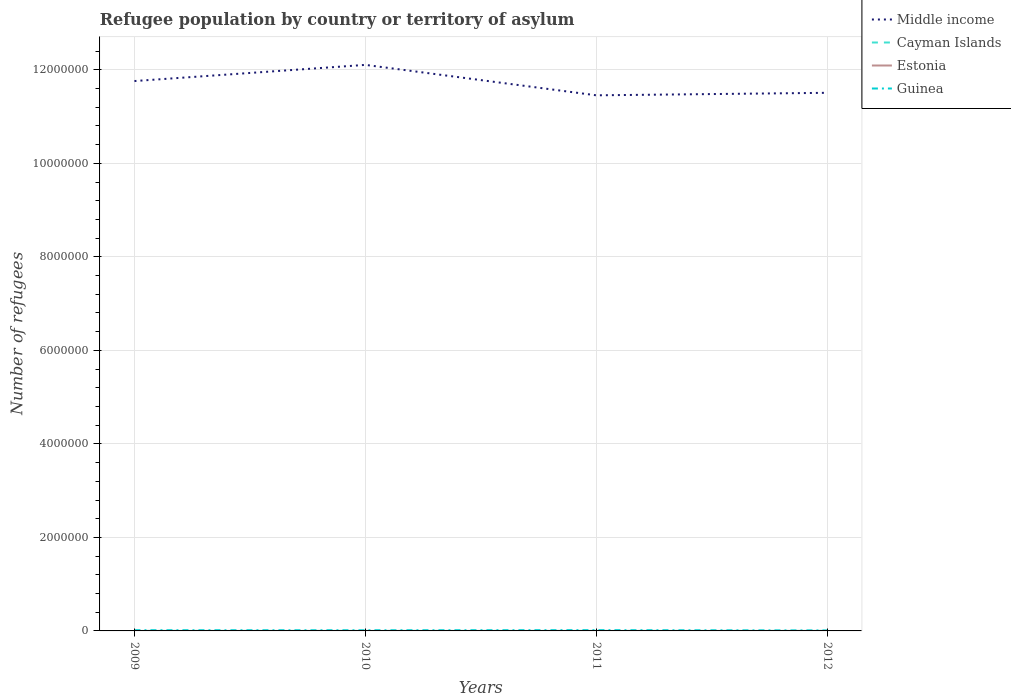Across all years, what is the maximum number of refugees in Estonia?
Offer a very short reply. 24. What is the total number of refugees in Guinea in the graph?
Ensure brevity in your answer.  -2496. What is the difference between the highest and the second highest number of refugees in Guinea?
Your answer should be very brief. 6238. What is the difference between the highest and the lowest number of refugees in Estonia?
Offer a very short reply. 2. Is the number of refugees in Estonia strictly greater than the number of refugees in Guinea over the years?
Give a very brief answer. Yes. How many years are there in the graph?
Give a very brief answer. 4. What is the difference between two consecutive major ticks on the Y-axis?
Offer a very short reply. 2.00e+06. Does the graph contain grids?
Your answer should be compact. Yes. Where does the legend appear in the graph?
Your response must be concise. Top right. How many legend labels are there?
Your response must be concise. 4. What is the title of the graph?
Your answer should be very brief. Refugee population by country or territory of asylum. Does "Marshall Islands" appear as one of the legend labels in the graph?
Provide a short and direct response. No. What is the label or title of the X-axis?
Offer a very short reply. Years. What is the label or title of the Y-axis?
Your answer should be very brief. Number of refugees. What is the Number of refugees in Middle income in 2009?
Your response must be concise. 1.18e+07. What is the Number of refugees of Cayman Islands in 2009?
Offer a very short reply. 1. What is the Number of refugees in Estonia in 2009?
Your answer should be compact. 24. What is the Number of refugees of Guinea in 2009?
Keep it short and to the point. 1.53e+04. What is the Number of refugees in Middle income in 2010?
Offer a very short reply. 1.21e+07. What is the Number of refugees in Estonia in 2010?
Offer a terse response. 39. What is the Number of refugees in Guinea in 2010?
Your answer should be compact. 1.41e+04. What is the Number of refugees in Middle income in 2011?
Ensure brevity in your answer.  1.15e+07. What is the Number of refugees of Guinea in 2011?
Offer a terse response. 1.66e+04. What is the Number of refugees of Middle income in 2012?
Provide a short and direct response. 1.15e+07. What is the Number of refugees of Guinea in 2012?
Give a very brief answer. 1.04e+04. Across all years, what is the maximum Number of refugees in Middle income?
Your answer should be very brief. 1.21e+07. Across all years, what is the maximum Number of refugees in Cayman Islands?
Ensure brevity in your answer.  3. Across all years, what is the maximum Number of refugees of Guinea?
Your response must be concise. 1.66e+04. Across all years, what is the minimum Number of refugees of Middle income?
Your response must be concise. 1.15e+07. Across all years, what is the minimum Number of refugees in Cayman Islands?
Make the answer very short. 1. Across all years, what is the minimum Number of refugees in Guinea?
Your answer should be very brief. 1.04e+04. What is the total Number of refugees of Middle income in the graph?
Give a very brief answer. 4.68e+07. What is the total Number of refugees in Cayman Islands in the graph?
Provide a short and direct response. 8. What is the total Number of refugees of Estonia in the graph?
Give a very brief answer. 176. What is the total Number of refugees of Guinea in the graph?
Your answer should be very brief. 5.64e+04. What is the difference between the Number of refugees in Middle income in 2009 and that in 2010?
Offer a very short reply. -3.46e+05. What is the difference between the Number of refugees of Guinea in 2009 and that in 2010?
Offer a terse response. 1212. What is the difference between the Number of refugees of Middle income in 2009 and that in 2011?
Give a very brief answer. 3.05e+05. What is the difference between the Number of refugees in Guinea in 2009 and that in 2011?
Provide a succinct answer. -1284. What is the difference between the Number of refugees in Middle income in 2009 and that in 2012?
Offer a very short reply. 2.52e+05. What is the difference between the Number of refugees in Estonia in 2009 and that in 2012?
Provide a succinct answer. -39. What is the difference between the Number of refugees of Guinea in 2009 and that in 2012?
Ensure brevity in your answer.  4954. What is the difference between the Number of refugees in Middle income in 2010 and that in 2011?
Ensure brevity in your answer.  6.51e+05. What is the difference between the Number of refugees of Guinea in 2010 and that in 2011?
Offer a terse response. -2496. What is the difference between the Number of refugees in Middle income in 2010 and that in 2012?
Provide a short and direct response. 5.97e+05. What is the difference between the Number of refugees in Cayman Islands in 2010 and that in 2012?
Give a very brief answer. -2. What is the difference between the Number of refugees of Estonia in 2010 and that in 2012?
Ensure brevity in your answer.  -24. What is the difference between the Number of refugees in Guinea in 2010 and that in 2012?
Offer a terse response. 3742. What is the difference between the Number of refugees in Middle income in 2011 and that in 2012?
Offer a terse response. -5.36e+04. What is the difference between the Number of refugees of Estonia in 2011 and that in 2012?
Provide a succinct answer. -13. What is the difference between the Number of refugees in Guinea in 2011 and that in 2012?
Give a very brief answer. 6238. What is the difference between the Number of refugees in Middle income in 2009 and the Number of refugees in Cayman Islands in 2010?
Your answer should be very brief. 1.18e+07. What is the difference between the Number of refugees in Middle income in 2009 and the Number of refugees in Estonia in 2010?
Give a very brief answer. 1.18e+07. What is the difference between the Number of refugees in Middle income in 2009 and the Number of refugees in Guinea in 2010?
Your answer should be compact. 1.17e+07. What is the difference between the Number of refugees of Cayman Islands in 2009 and the Number of refugees of Estonia in 2010?
Make the answer very short. -38. What is the difference between the Number of refugees in Cayman Islands in 2009 and the Number of refugees in Guinea in 2010?
Your answer should be very brief. -1.41e+04. What is the difference between the Number of refugees of Estonia in 2009 and the Number of refugees of Guinea in 2010?
Offer a very short reply. -1.41e+04. What is the difference between the Number of refugees of Middle income in 2009 and the Number of refugees of Cayman Islands in 2011?
Ensure brevity in your answer.  1.18e+07. What is the difference between the Number of refugees of Middle income in 2009 and the Number of refugees of Estonia in 2011?
Give a very brief answer. 1.18e+07. What is the difference between the Number of refugees of Middle income in 2009 and the Number of refugees of Guinea in 2011?
Keep it short and to the point. 1.17e+07. What is the difference between the Number of refugees of Cayman Islands in 2009 and the Number of refugees of Estonia in 2011?
Ensure brevity in your answer.  -49. What is the difference between the Number of refugees in Cayman Islands in 2009 and the Number of refugees in Guinea in 2011?
Your response must be concise. -1.66e+04. What is the difference between the Number of refugees of Estonia in 2009 and the Number of refugees of Guinea in 2011?
Provide a short and direct response. -1.66e+04. What is the difference between the Number of refugees of Middle income in 2009 and the Number of refugees of Cayman Islands in 2012?
Keep it short and to the point. 1.18e+07. What is the difference between the Number of refugees in Middle income in 2009 and the Number of refugees in Estonia in 2012?
Make the answer very short. 1.18e+07. What is the difference between the Number of refugees in Middle income in 2009 and the Number of refugees in Guinea in 2012?
Your response must be concise. 1.18e+07. What is the difference between the Number of refugees in Cayman Islands in 2009 and the Number of refugees in Estonia in 2012?
Offer a terse response. -62. What is the difference between the Number of refugees of Cayman Islands in 2009 and the Number of refugees of Guinea in 2012?
Offer a terse response. -1.04e+04. What is the difference between the Number of refugees of Estonia in 2009 and the Number of refugees of Guinea in 2012?
Your answer should be very brief. -1.03e+04. What is the difference between the Number of refugees in Middle income in 2010 and the Number of refugees in Cayman Islands in 2011?
Provide a succinct answer. 1.21e+07. What is the difference between the Number of refugees in Middle income in 2010 and the Number of refugees in Estonia in 2011?
Your answer should be very brief. 1.21e+07. What is the difference between the Number of refugees in Middle income in 2010 and the Number of refugees in Guinea in 2011?
Your response must be concise. 1.21e+07. What is the difference between the Number of refugees of Cayman Islands in 2010 and the Number of refugees of Estonia in 2011?
Offer a terse response. -49. What is the difference between the Number of refugees in Cayman Islands in 2010 and the Number of refugees in Guinea in 2011?
Ensure brevity in your answer.  -1.66e+04. What is the difference between the Number of refugees of Estonia in 2010 and the Number of refugees of Guinea in 2011?
Your answer should be very brief. -1.66e+04. What is the difference between the Number of refugees in Middle income in 2010 and the Number of refugees in Cayman Islands in 2012?
Give a very brief answer. 1.21e+07. What is the difference between the Number of refugees in Middle income in 2010 and the Number of refugees in Estonia in 2012?
Make the answer very short. 1.21e+07. What is the difference between the Number of refugees of Middle income in 2010 and the Number of refugees of Guinea in 2012?
Provide a succinct answer. 1.21e+07. What is the difference between the Number of refugees in Cayman Islands in 2010 and the Number of refugees in Estonia in 2012?
Make the answer very short. -62. What is the difference between the Number of refugees of Cayman Islands in 2010 and the Number of refugees of Guinea in 2012?
Ensure brevity in your answer.  -1.04e+04. What is the difference between the Number of refugees of Estonia in 2010 and the Number of refugees of Guinea in 2012?
Make the answer very short. -1.03e+04. What is the difference between the Number of refugees in Middle income in 2011 and the Number of refugees in Cayman Islands in 2012?
Provide a succinct answer. 1.15e+07. What is the difference between the Number of refugees of Middle income in 2011 and the Number of refugees of Estonia in 2012?
Your answer should be very brief. 1.15e+07. What is the difference between the Number of refugees in Middle income in 2011 and the Number of refugees in Guinea in 2012?
Keep it short and to the point. 1.14e+07. What is the difference between the Number of refugees of Cayman Islands in 2011 and the Number of refugees of Estonia in 2012?
Your answer should be very brief. -60. What is the difference between the Number of refugees of Cayman Islands in 2011 and the Number of refugees of Guinea in 2012?
Keep it short and to the point. -1.04e+04. What is the difference between the Number of refugees in Estonia in 2011 and the Number of refugees in Guinea in 2012?
Your answer should be compact. -1.03e+04. What is the average Number of refugees of Middle income per year?
Provide a short and direct response. 1.17e+07. What is the average Number of refugees of Guinea per year?
Offer a very short reply. 1.41e+04. In the year 2009, what is the difference between the Number of refugees in Middle income and Number of refugees in Cayman Islands?
Offer a very short reply. 1.18e+07. In the year 2009, what is the difference between the Number of refugees in Middle income and Number of refugees in Estonia?
Give a very brief answer. 1.18e+07. In the year 2009, what is the difference between the Number of refugees of Middle income and Number of refugees of Guinea?
Your answer should be compact. 1.17e+07. In the year 2009, what is the difference between the Number of refugees in Cayman Islands and Number of refugees in Estonia?
Offer a very short reply. -23. In the year 2009, what is the difference between the Number of refugees in Cayman Islands and Number of refugees in Guinea?
Give a very brief answer. -1.53e+04. In the year 2009, what is the difference between the Number of refugees of Estonia and Number of refugees of Guinea?
Provide a short and direct response. -1.53e+04. In the year 2010, what is the difference between the Number of refugees in Middle income and Number of refugees in Cayman Islands?
Your answer should be very brief. 1.21e+07. In the year 2010, what is the difference between the Number of refugees in Middle income and Number of refugees in Estonia?
Ensure brevity in your answer.  1.21e+07. In the year 2010, what is the difference between the Number of refugees in Middle income and Number of refugees in Guinea?
Offer a very short reply. 1.21e+07. In the year 2010, what is the difference between the Number of refugees in Cayman Islands and Number of refugees in Estonia?
Your answer should be very brief. -38. In the year 2010, what is the difference between the Number of refugees in Cayman Islands and Number of refugees in Guinea?
Ensure brevity in your answer.  -1.41e+04. In the year 2010, what is the difference between the Number of refugees of Estonia and Number of refugees of Guinea?
Provide a succinct answer. -1.41e+04. In the year 2011, what is the difference between the Number of refugees in Middle income and Number of refugees in Cayman Islands?
Your answer should be very brief. 1.15e+07. In the year 2011, what is the difference between the Number of refugees of Middle income and Number of refugees of Estonia?
Provide a succinct answer. 1.15e+07. In the year 2011, what is the difference between the Number of refugees in Middle income and Number of refugees in Guinea?
Offer a very short reply. 1.14e+07. In the year 2011, what is the difference between the Number of refugees of Cayman Islands and Number of refugees of Estonia?
Ensure brevity in your answer.  -47. In the year 2011, what is the difference between the Number of refugees in Cayman Islands and Number of refugees in Guinea?
Make the answer very short. -1.66e+04. In the year 2011, what is the difference between the Number of refugees of Estonia and Number of refugees of Guinea?
Make the answer very short. -1.66e+04. In the year 2012, what is the difference between the Number of refugees of Middle income and Number of refugees of Cayman Islands?
Keep it short and to the point. 1.15e+07. In the year 2012, what is the difference between the Number of refugees of Middle income and Number of refugees of Estonia?
Ensure brevity in your answer.  1.15e+07. In the year 2012, what is the difference between the Number of refugees of Middle income and Number of refugees of Guinea?
Your answer should be compact. 1.15e+07. In the year 2012, what is the difference between the Number of refugees in Cayman Islands and Number of refugees in Estonia?
Make the answer very short. -60. In the year 2012, what is the difference between the Number of refugees of Cayman Islands and Number of refugees of Guinea?
Provide a short and direct response. -1.04e+04. In the year 2012, what is the difference between the Number of refugees in Estonia and Number of refugees in Guinea?
Provide a succinct answer. -1.03e+04. What is the ratio of the Number of refugees of Middle income in 2009 to that in 2010?
Provide a short and direct response. 0.97. What is the ratio of the Number of refugees of Estonia in 2009 to that in 2010?
Your answer should be compact. 0.62. What is the ratio of the Number of refugees of Guinea in 2009 to that in 2010?
Make the answer very short. 1.09. What is the ratio of the Number of refugees of Middle income in 2009 to that in 2011?
Provide a short and direct response. 1.03. What is the ratio of the Number of refugees of Cayman Islands in 2009 to that in 2011?
Give a very brief answer. 0.33. What is the ratio of the Number of refugees of Estonia in 2009 to that in 2011?
Your response must be concise. 0.48. What is the ratio of the Number of refugees of Guinea in 2009 to that in 2011?
Your answer should be compact. 0.92. What is the ratio of the Number of refugees of Middle income in 2009 to that in 2012?
Provide a short and direct response. 1.02. What is the ratio of the Number of refugees in Estonia in 2009 to that in 2012?
Ensure brevity in your answer.  0.38. What is the ratio of the Number of refugees of Guinea in 2009 to that in 2012?
Provide a short and direct response. 1.48. What is the ratio of the Number of refugees in Middle income in 2010 to that in 2011?
Keep it short and to the point. 1.06. What is the ratio of the Number of refugees of Estonia in 2010 to that in 2011?
Ensure brevity in your answer.  0.78. What is the ratio of the Number of refugees in Guinea in 2010 to that in 2011?
Keep it short and to the point. 0.85. What is the ratio of the Number of refugees in Middle income in 2010 to that in 2012?
Keep it short and to the point. 1.05. What is the ratio of the Number of refugees of Estonia in 2010 to that in 2012?
Offer a very short reply. 0.62. What is the ratio of the Number of refugees in Guinea in 2010 to that in 2012?
Your answer should be compact. 1.36. What is the ratio of the Number of refugees of Estonia in 2011 to that in 2012?
Your response must be concise. 0.79. What is the ratio of the Number of refugees in Guinea in 2011 to that in 2012?
Make the answer very short. 1.6. What is the difference between the highest and the second highest Number of refugees in Middle income?
Provide a succinct answer. 3.46e+05. What is the difference between the highest and the second highest Number of refugees in Guinea?
Offer a very short reply. 1284. What is the difference between the highest and the lowest Number of refugees in Middle income?
Your answer should be very brief. 6.51e+05. What is the difference between the highest and the lowest Number of refugees in Guinea?
Your response must be concise. 6238. 